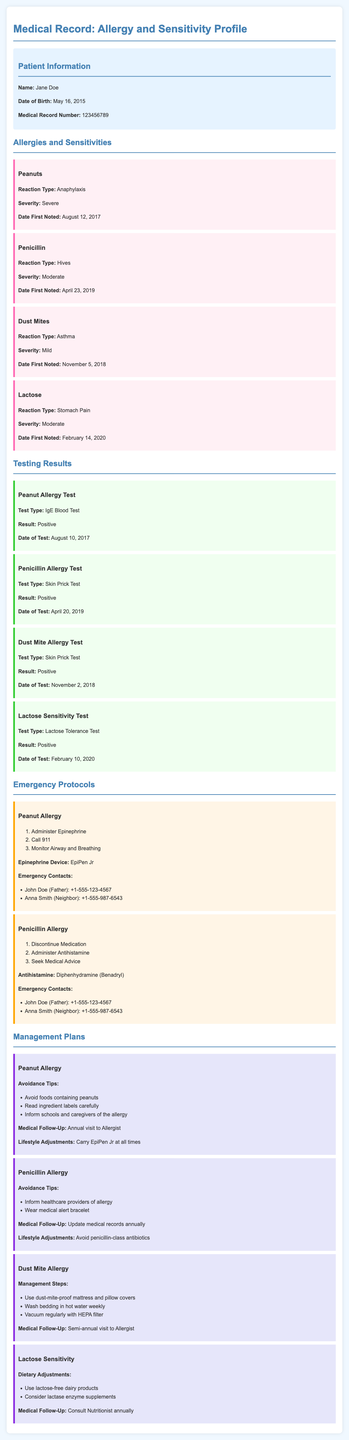What is the patient's name? The patient's name is located in the patient information section of the document.
Answer: Jane Doe What is the reaction type for the peanut allergy? The reaction type for peanuts is detailed under the allergies and sensitivities section of the document.
Answer: Anaphylaxis When was the lactose sensitivity test conducted? The date of the lactose sensitivity test can be found in the testing results section.
Answer: February 10, 2020 How severe is the reaction to dust mites? The severity level for the dust mite allergy is stated in the allergy and sensitivity profiles.
Answer: Mild What are the avoidance tips for penicillin allergy? The avoidance tips for the penicillin allergy are listed in the management plans section.
Answer: Inform healthcare providers of allergy, Wear medical alert bracelet What is the emergency contact number for John Doe? John Doe's contact number is provided under the emergency protocols section.
Answer: +1-555-123-4567 What type of test confirmed the peanut allergy? The type of test for the peanut allergy is specified in the testing results section.
Answer: IgE Blood Test What lifestyle adjustment is recommended for a peanut allergy? The lifestyle adjustment for a peanut allergy is mentioned in the management plans section.
Answer: Carry EpiPen Jr at all times How often should the patient visit the allergist for dust mite allergy? The frequency of visits to the allergist for dust mite allergy is noted in the management plans.
Answer: Semi-annual 